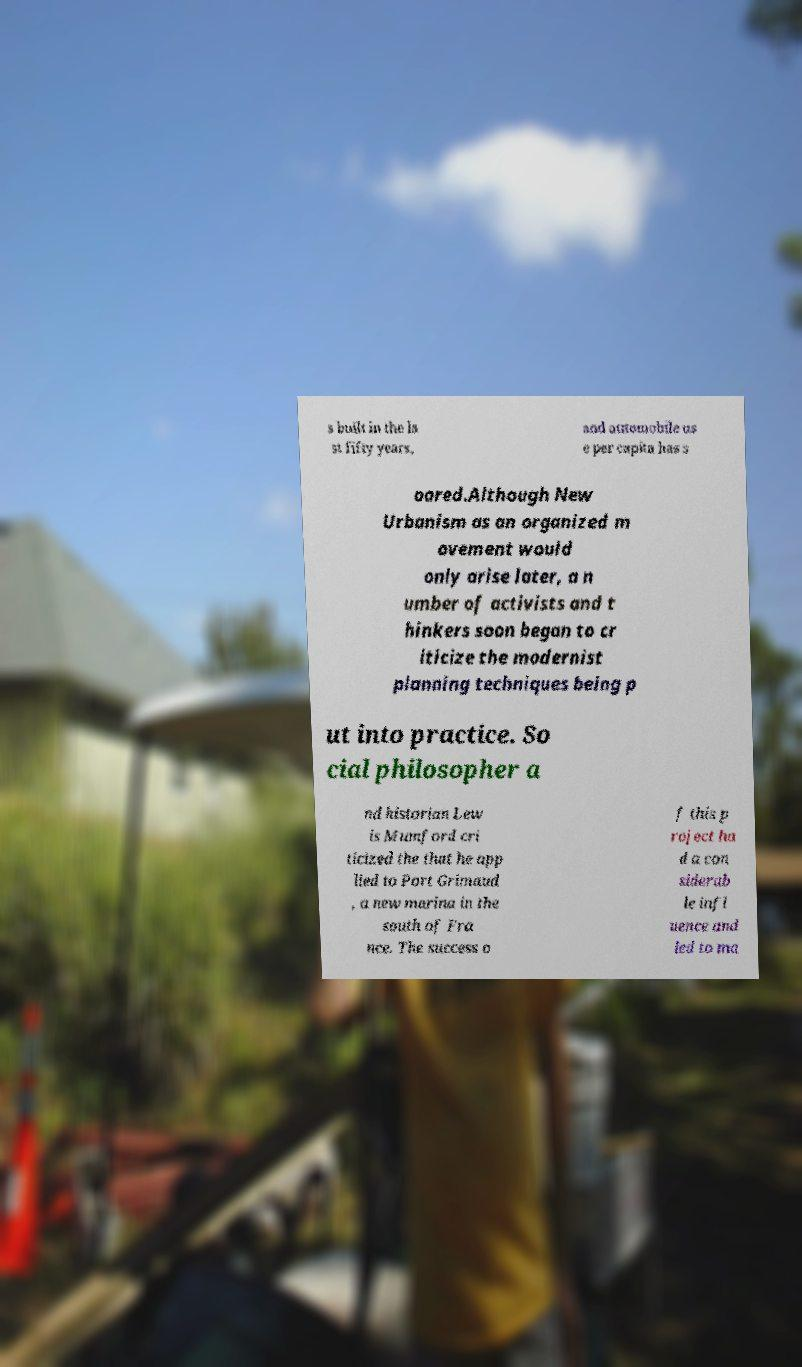What messages or text are displayed in this image? I need them in a readable, typed format. s built in the la st fifty years, and automobile us e per capita has s oared.Although New Urbanism as an organized m ovement would only arise later, a n umber of activists and t hinkers soon began to cr iticize the modernist planning techniques being p ut into practice. So cial philosopher a nd historian Lew is Mumford cri ticized the that he app lied to Port Grimaud , a new marina in the south of Fra nce. The success o f this p roject ha d a con siderab le infl uence and led to ma 